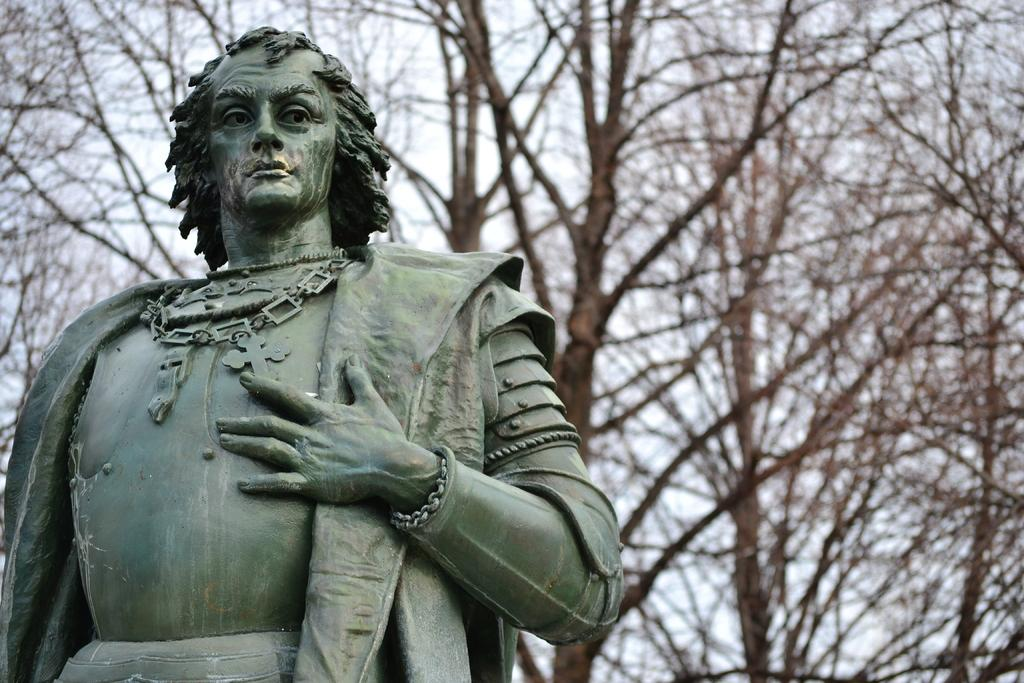What is the main subject of the image? There is a sculpture of a man in the image. What is the color of the sculpture? The sculpture is black in color. What type of vegetation can be seen in the image? There are dried trees visible in the image. What part of the natural environment is visible in the image? A part of the sky is visible in the image. What type of potato is being used to care for the iron in the image? There is no potato or iron present in the image, and therefore no such activity can be observed. 